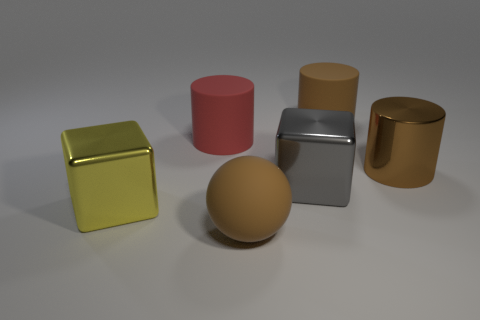Are the large cube to the left of the large gray cube and the thing that is behind the red rubber thing made of the same material?
Give a very brief answer. No. What material is the yellow object?
Offer a terse response. Metal. What number of other objects are there of the same color as the big metal cylinder?
Offer a terse response. 2. Do the big metal cylinder and the large sphere have the same color?
Make the answer very short. Yes. How many purple metal blocks are there?
Your response must be concise. 0. The large block on the right side of the large metallic block on the left side of the red rubber cylinder is made of what material?
Your answer should be compact. Metal. There is another brown cylinder that is the same size as the brown rubber cylinder; what is its material?
Your answer should be compact. Metal. Is the size of the brown matte object that is on the right side of the gray object the same as the red cylinder?
Your answer should be compact. Yes. Do the brown matte thing that is on the left side of the large brown matte cylinder and the big brown shiny thing have the same shape?
Keep it short and to the point. No. What number of objects are either gray objects or blocks right of the matte sphere?
Offer a terse response. 1. 